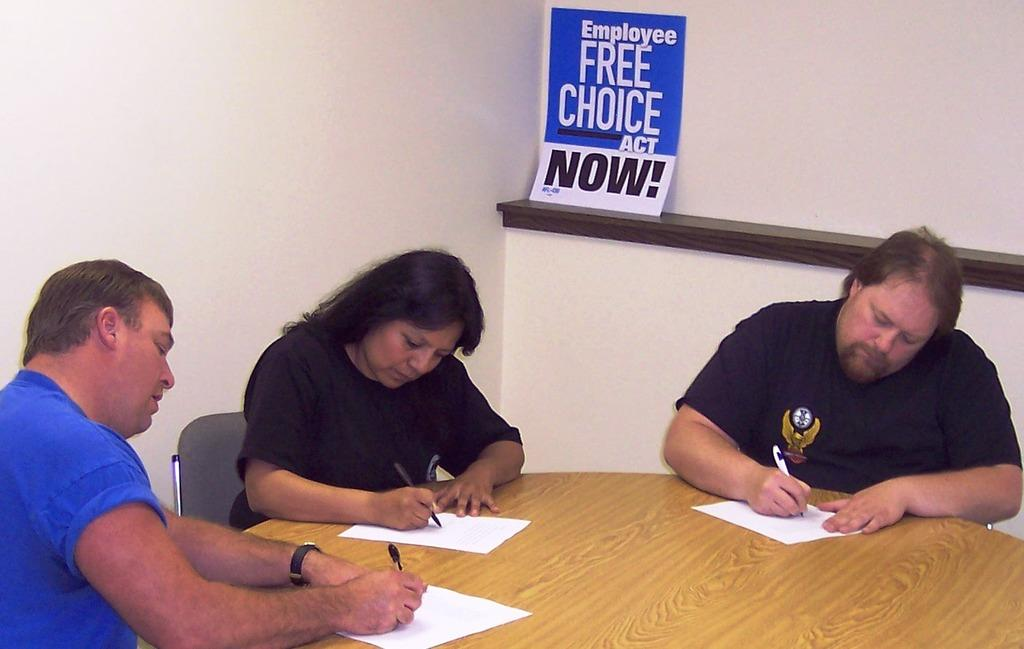How many people are in the image? There are three members in the image. What are the members doing in the image? The members are sitting on chairs and writing on papers. What is in front of the members? The members are in front of a table. What can be seen in the background of the image? There is a wall in the background of the image. What type of pet can be seen playing with a ball in the image? There is no pet or ball present in the image; it features three members sitting on chairs and writing on papers. 